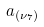<formula> <loc_0><loc_0><loc_500><loc_500>a _ { ( \nu _ { 7 } ) }</formula> 